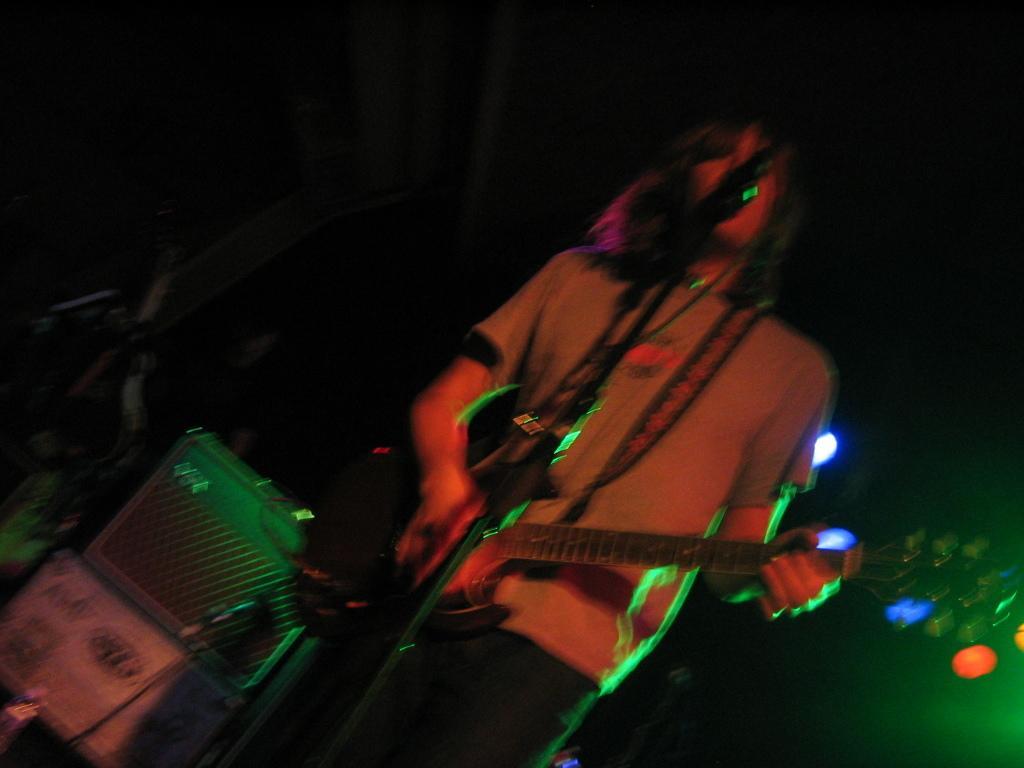Describe this image in one or two sentences. A man is standing and playing guitar,behind him there are boxes and light. 